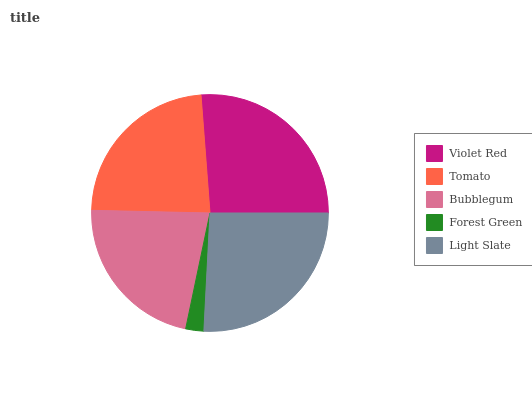Is Forest Green the minimum?
Answer yes or no. Yes. Is Violet Red the maximum?
Answer yes or no. Yes. Is Tomato the minimum?
Answer yes or no. No. Is Tomato the maximum?
Answer yes or no. No. Is Violet Red greater than Tomato?
Answer yes or no. Yes. Is Tomato less than Violet Red?
Answer yes or no. Yes. Is Tomato greater than Violet Red?
Answer yes or no. No. Is Violet Red less than Tomato?
Answer yes or no. No. Is Tomato the high median?
Answer yes or no. Yes. Is Tomato the low median?
Answer yes or no. Yes. Is Light Slate the high median?
Answer yes or no. No. Is Forest Green the low median?
Answer yes or no. No. 